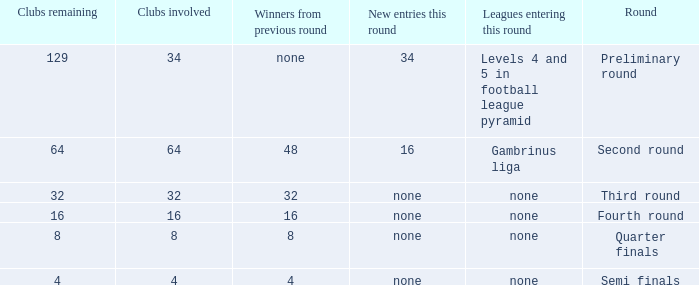Name the leagues entering this round for 4 None. 